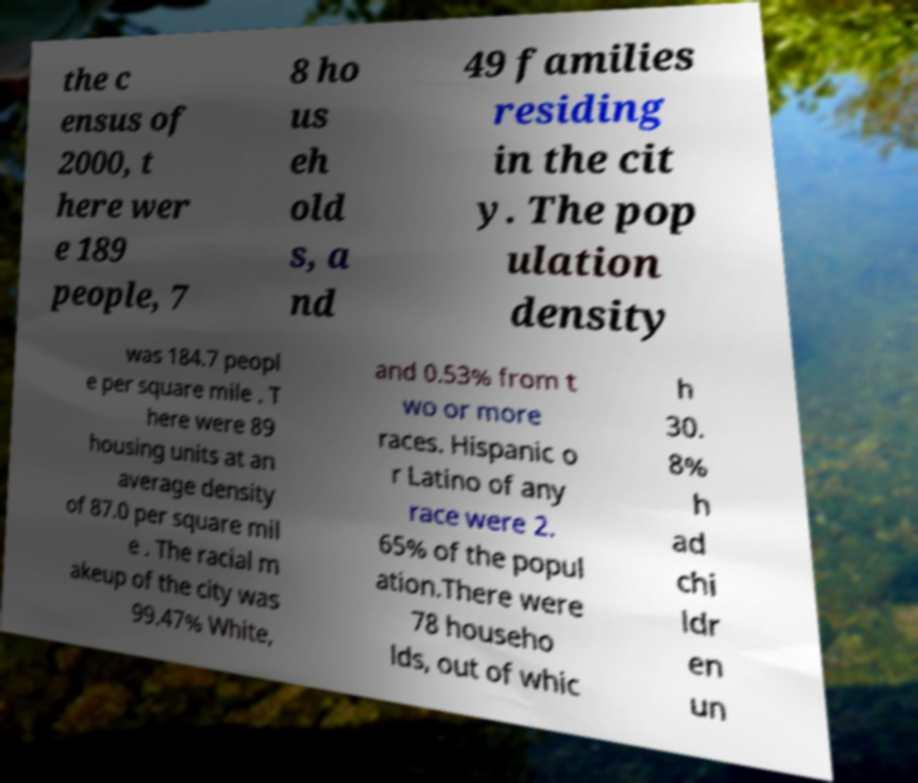Please identify and transcribe the text found in this image. the c ensus of 2000, t here wer e 189 people, 7 8 ho us eh old s, a nd 49 families residing in the cit y. The pop ulation density was 184.7 peopl e per square mile . T here were 89 housing units at an average density of 87.0 per square mil e . The racial m akeup of the city was 99.47% White, and 0.53% from t wo or more races. Hispanic o r Latino of any race were 2. 65% of the popul ation.There were 78 househo lds, out of whic h 30. 8% h ad chi ldr en un 